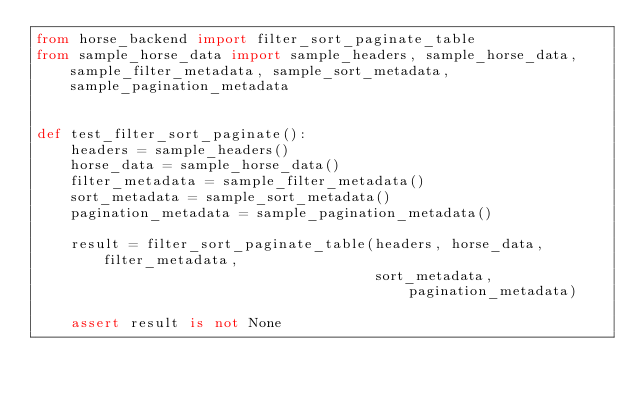Convert code to text. <code><loc_0><loc_0><loc_500><loc_500><_Python_>from horse_backend import filter_sort_paginate_table
from sample_horse_data import sample_headers, sample_horse_data, sample_filter_metadata, sample_sort_metadata, sample_pagination_metadata


def test_filter_sort_paginate():
    headers = sample_headers()
    horse_data = sample_horse_data()
    filter_metadata = sample_filter_metadata()
    sort_metadata = sample_sort_metadata()
    pagination_metadata = sample_pagination_metadata()

    result = filter_sort_paginate_table(headers, horse_data, filter_metadata,
                                        sort_metadata, pagination_metadata)

    assert result is not None
</code> 